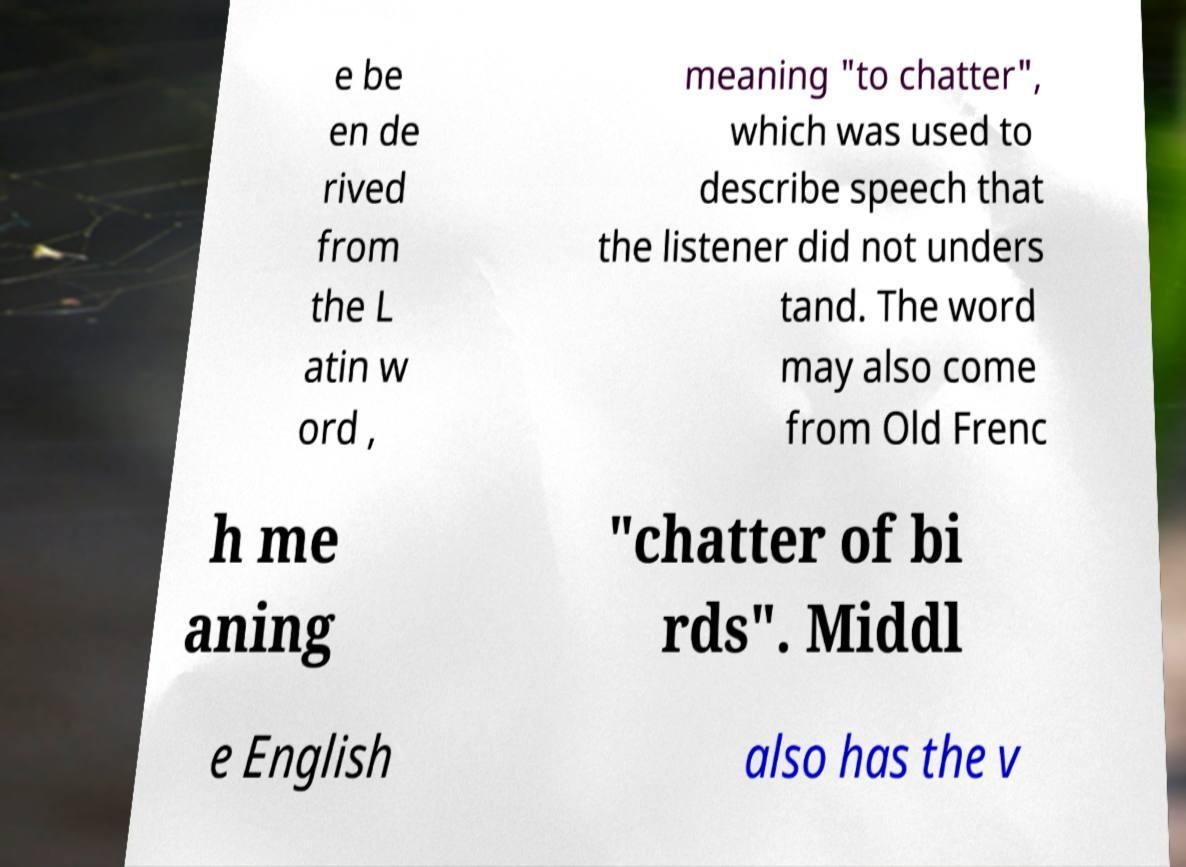Please read and relay the text visible in this image. What does it say? e be en de rived from the L atin w ord , meaning "to chatter", which was used to describe speech that the listener did not unders tand. The word may also come from Old Frenc h me aning "chatter of bi rds". Middl e English also has the v 